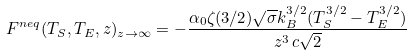Convert formula to latex. <formula><loc_0><loc_0><loc_500><loc_500>F ^ { n e q } ( T _ { S } , T _ { E } , z ) _ { z \to \infty } = - \frac { \alpha _ { 0 } \zeta ( 3 / 2 ) \sqrt { \sigma } k _ { B } ^ { 3 / 2 } ( T _ { S } ^ { 3 / 2 } - T _ { E } ^ { 3 / 2 } ) } { z ^ { 3 } \, c \sqrt { 2 } }</formula> 